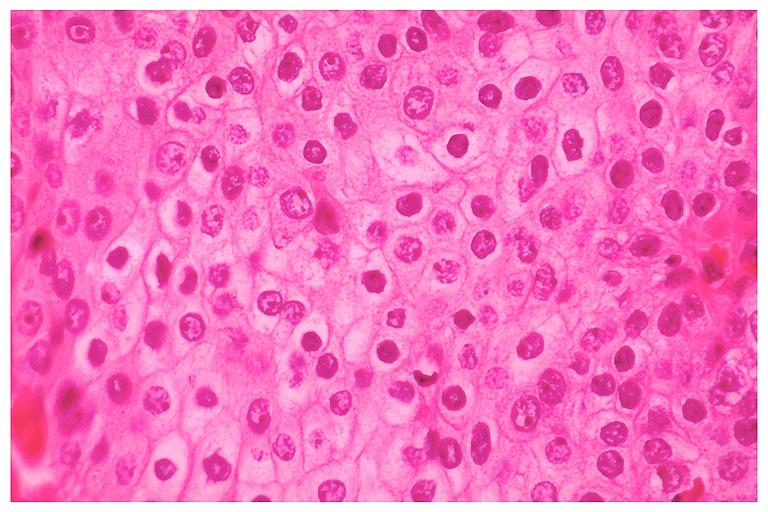what is present?
Answer the question using a single word or phrase. Oral 